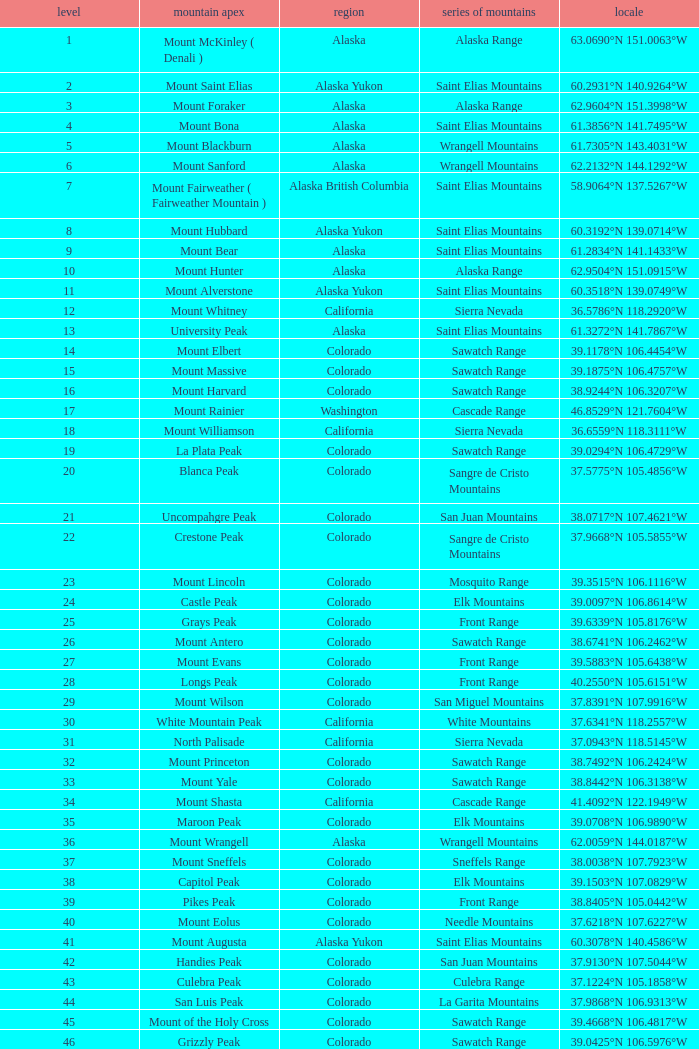What is the mountain range when the mountain peak is mauna kea? Island of Hawai ʻ i. 